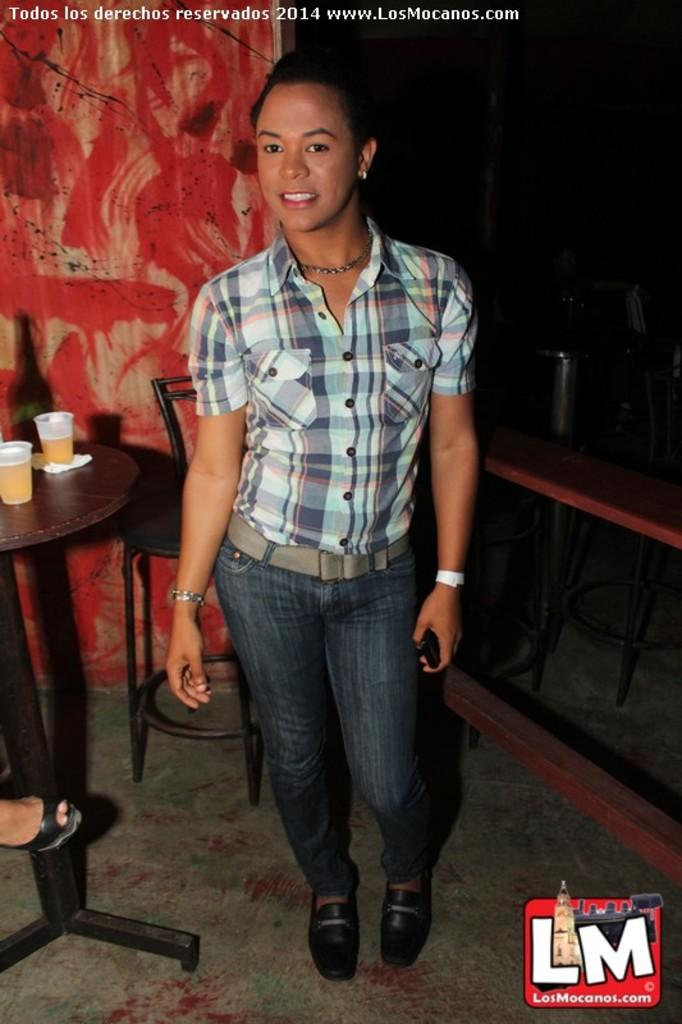Who is the main subject in the image? There is a lady in the image. What is the lady wearing? The lady is wearing a blue shirt and blue jeans. What furniture can be seen in the image? There is a table and a chair in the image. What objects are on the table? There are two glasses on the table. Can you describe the plot of the story unfolding in the image? There is no story or plot depicted in the image; it is a static scene featuring a lady, her clothing, and some furniture and objects. Are there any clams visible in the image? No, there are no clams present in the image. 